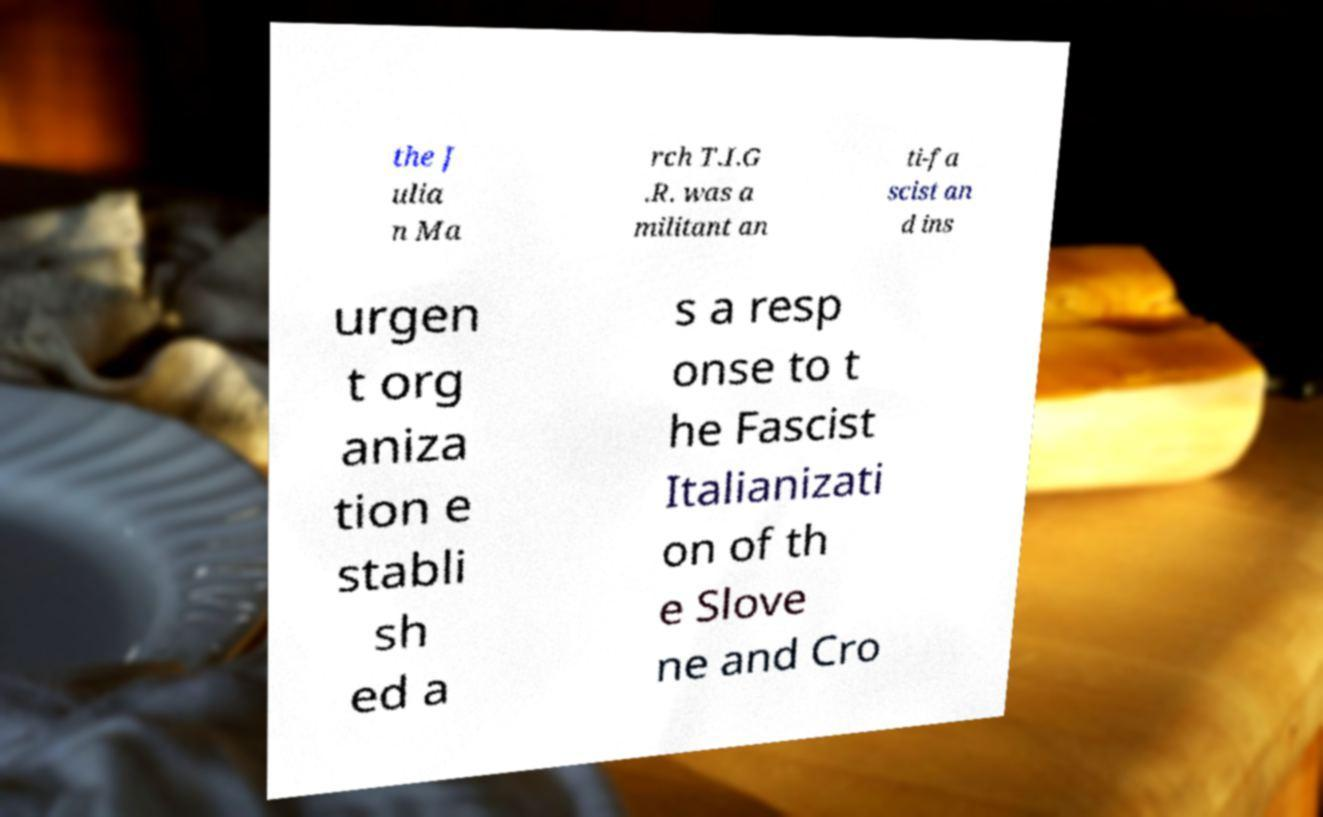For documentation purposes, I need the text within this image transcribed. Could you provide that? the J ulia n Ma rch T.I.G .R. was a militant an ti-fa scist an d ins urgen t org aniza tion e stabli sh ed a s a resp onse to t he Fascist Italianizati on of th e Slove ne and Cro 